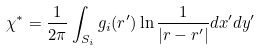<formula> <loc_0><loc_0><loc_500><loc_500>\chi ^ { * } = \frac { 1 } { 2 \pi } \int _ { S _ { i } } g _ { i } ( { r } ^ { \prime } ) \ln \frac { 1 } { \left | { { r } - { r } ^ { \prime } } \right | } d x ^ { \prime } d y ^ { \prime }</formula> 